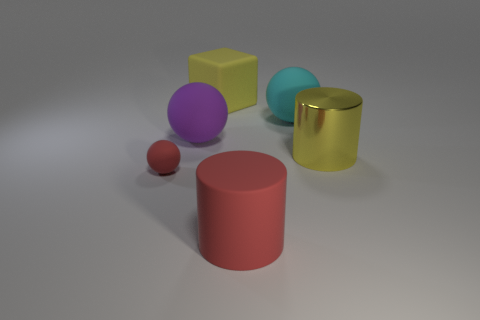There is a small ball on the left side of the big rubber cube; is its color the same as the cylinder on the left side of the yellow metal cylinder?
Provide a short and direct response. Yes. The metal object has what color?
Give a very brief answer. Yellow. What color is the big thing that is in front of the big purple rubber thing and on the left side of the big cyan rubber thing?
Your response must be concise. Red. There is a cyan thing right of the yellow rubber thing; does it have the same size as the tiny rubber ball?
Provide a short and direct response. No. Is the number of purple things behind the red matte sphere greater than the number of large gray rubber cubes?
Offer a very short reply. Yes. Is the large red object the same shape as the metal object?
Offer a very short reply. Yes. What is the size of the red matte sphere?
Offer a terse response. Small. Is the number of red rubber things that are to the right of the large yellow block greater than the number of yellow matte cubes that are in front of the purple rubber ball?
Offer a very short reply. Yes. Are there any matte cubes to the left of the yellow metallic cylinder?
Your answer should be very brief. Yes. Is there a red matte cylinder of the same size as the cyan object?
Give a very brief answer. Yes. 